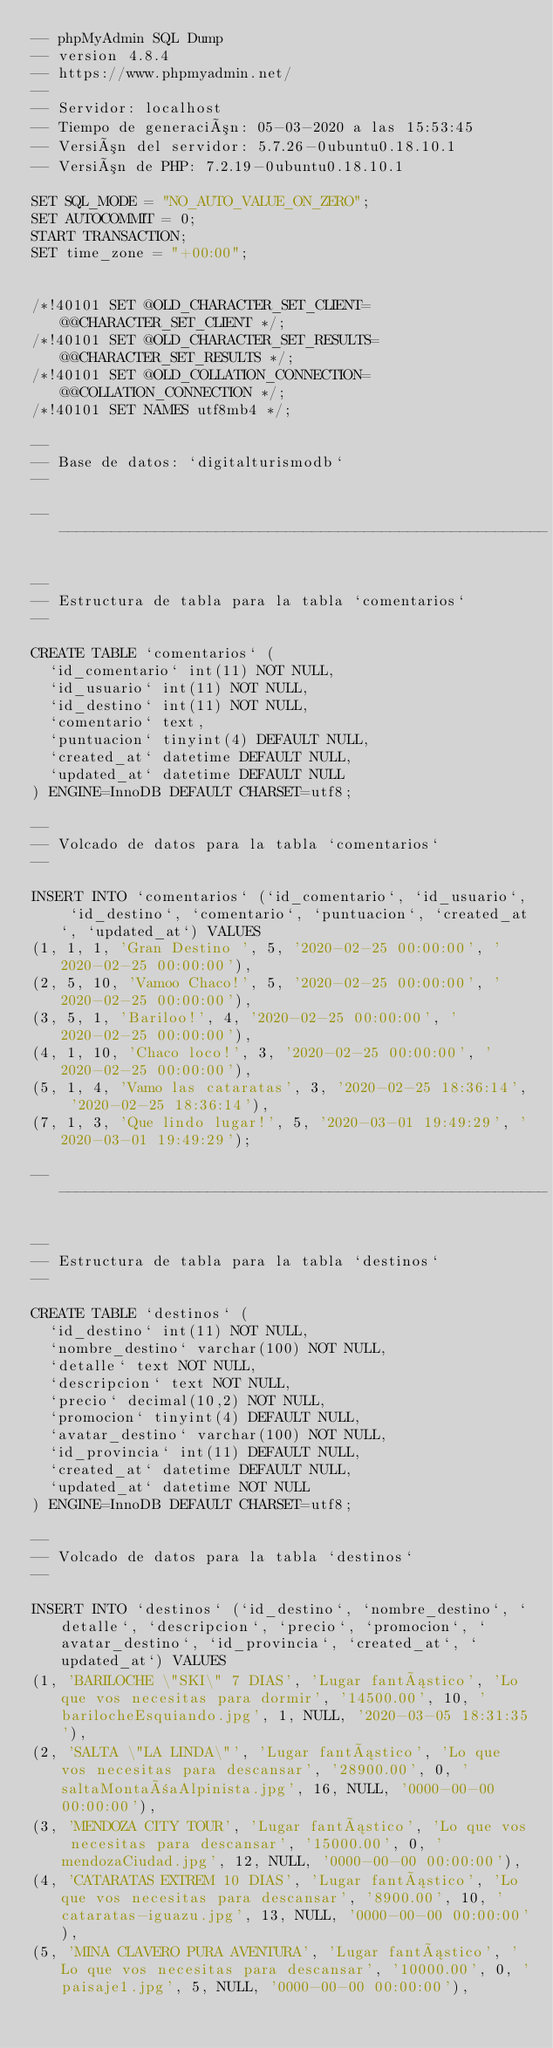<code> <loc_0><loc_0><loc_500><loc_500><_SQL_>-- phpMyAdmin SQL Dump
-- version 4.8.4
-- https://www.phpmyadmin.net/
--
-- Servidor: localhost
-- Tiempo de generación: 05-03-2020 a las 15:53:45
-- Versión del servidor: 5.7.26-0ubuntu0.18.10.1
-- Versión de PHP: 7.2.19-0ubuntu0.18.10.1

SET SQL_MODE = "NO_AUTO_VALUE_ON_ZERO";
SET AUTOCOMMIT = 0;
START TRANSACTION;
SET time_zone = "+00:00";


/*!40101 SET @OLD_CHARACTER_SET_CLIENT=@@CHARACTER_SET_CLIENT */;
/*!40101 SET @OLD_CHARACTER_SET_RESULTS=@@CHARACTER_SET_RESULTS */;
/*!40101 SET @OLD_COLLATION_CONNECTION=@@COLLATION_CONNECTION */;
/*!40101 SET NAMES utf8mb4 */;

--
-- Base de datos: `digitalturismodb`
--

-- --------------------------------------------------------

--
-- Estructura de tabla para la tabla `comentarios`
--

CREATE TABLE `comentarios` (
  `id_comentario` int(11) NOT NULL,
  `id_usuario` int(11) NOT NULL,
  `id_destino` int(11) NOT NULL,
  `comentario` text,
  `puntuacion` tinyint(4) DEFAULT NULL,
  `created_at` datetime DEFAULT NULL,
  `updated_at` datetime DEFAULT NULL
) ENGINE=InnoDB DEFAULT CHARSET=utf8;

--
-- Volcado de datos para la tabla `comentarios`
--

INSERT INTO `comentarios` (`id_comentario`, `id_usuario`, `id_destino`, `comentario`, `puntuacion`, `created_at`, `updated_at`) VALUES
(1, 1, 1, 'Gran Destino ', 5, '2020-02-25 00:00:00', '2020-02-25 00:00:00'),
(2, 5, 10, 'Vamoo Chaco!', 5, '2020-02-25 00:00:00', '2020-02-25 00:00:00'),
(3, 5, 1, 'Bariloo!', 4, '2020-02-25 00:00:00', '2020-02-25 00:00:00'),
(4, 1, 10, 'Chaco loco!', 3, '2020-02-25 00:00:00', '2020-02-25 00:00:00'),
(5, 1, 4, 'Vamo las cataratas', 3, '2020-02-25 18:36:14', '2020-02-25 18:36:14'),
(7, 1, 3, 'Que lindo lugar!', 5, '2020-03-01 19:49:29', '2020-03-01 19:49:29');

-- --------------------------------------------------------

--
-- Estructura de tabla para la tabla `destinos`
--

CREATE TABLE `destinos` (
  `id_destino` int(11) NOT NULL,
  `nombre_destino` varchar(100) NOT NULL,
  `detalle` text NOT NULL,
  `descripcion` text NOT NULL,
  `precio` decimal(10,2) NOT NULL,
  `promocion` tinyint(4) DEFAULT NULL,
  `avatar_destino` varchar(100) NOT NULL,
  `id_provincia` int(11) DEFAULT NULL,
  `created_at` datetime DEFAULT NULL,
  `updated_at` datetime NOT NULL
) ENGINE=InnoDB DEFAULT CHARSET=utf8;

--
-- Volcado de datos para la tabla `destinos`
--

INSERT INTO `destinos` (`id_destino`, `nombre_destino`, `detalle`, `descripcion`, `precio`, `promocion`, `avatar_destino`, `id_provincia`, `created_at`, `updated_at`) VALUES
(1, 'BARILOCHE \"SKI\" 7 DIAS', 'Lugar fantástico', 'Lo que vos necesitas para dormir', '14500.00', 10, 'barilocheEsquiando.jpg', 1, NULL, '2020-03-05 18:31:35'),
(2, 'SALTA \"LA LINDA\"', 'Lugar fantástico', 'Lo que vos necesitas para descansar', '28900.00', 0, 'saltaMontañaAlpinista.jpg', 16, NULL, '0000-00-00 00:00:00'),
(3, 'MENDOZA CITY TOUR', 'Lugar fantástico', 'Lo que vos necesitas para descansar', '15000.00', 0, 'mendozaCiudad.jpg', 12, NULL, '0000-00-00 00:00:00'),
(4, 'CATARATAS EXTREM 10 DIAS', 'Lugar fantástico', 'Lo que vos necesitas para descansar', '8900.00', 10, 'cataratas-iguazu.jpg', 13, NULL, '0000-00-00 00:00:00'),
(5, 'MINA CLAVERO PURA AVENTURA', 'Lugar fantástico', 'Lo que vos necesitas para descansar', '10000.00', 0, 'paisaje1.jpg', 5, NULL, '0000-00-00 00:00:00'),</code> 